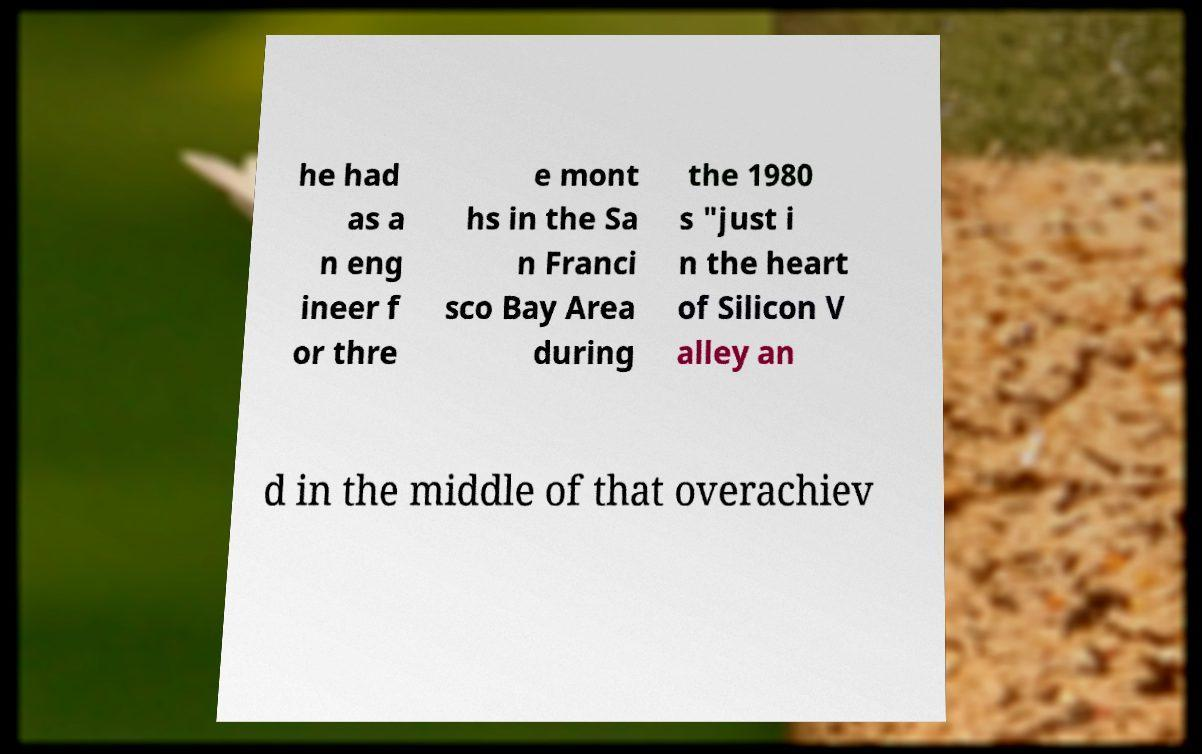Could you extract and type out the text from this image? he had as a n eng ineer f or thre e mont hs in the Sa n Franci sco Bay Area during the 1980 s "just i n the heart of Silicon V alley an d in the middle of that overachiev 